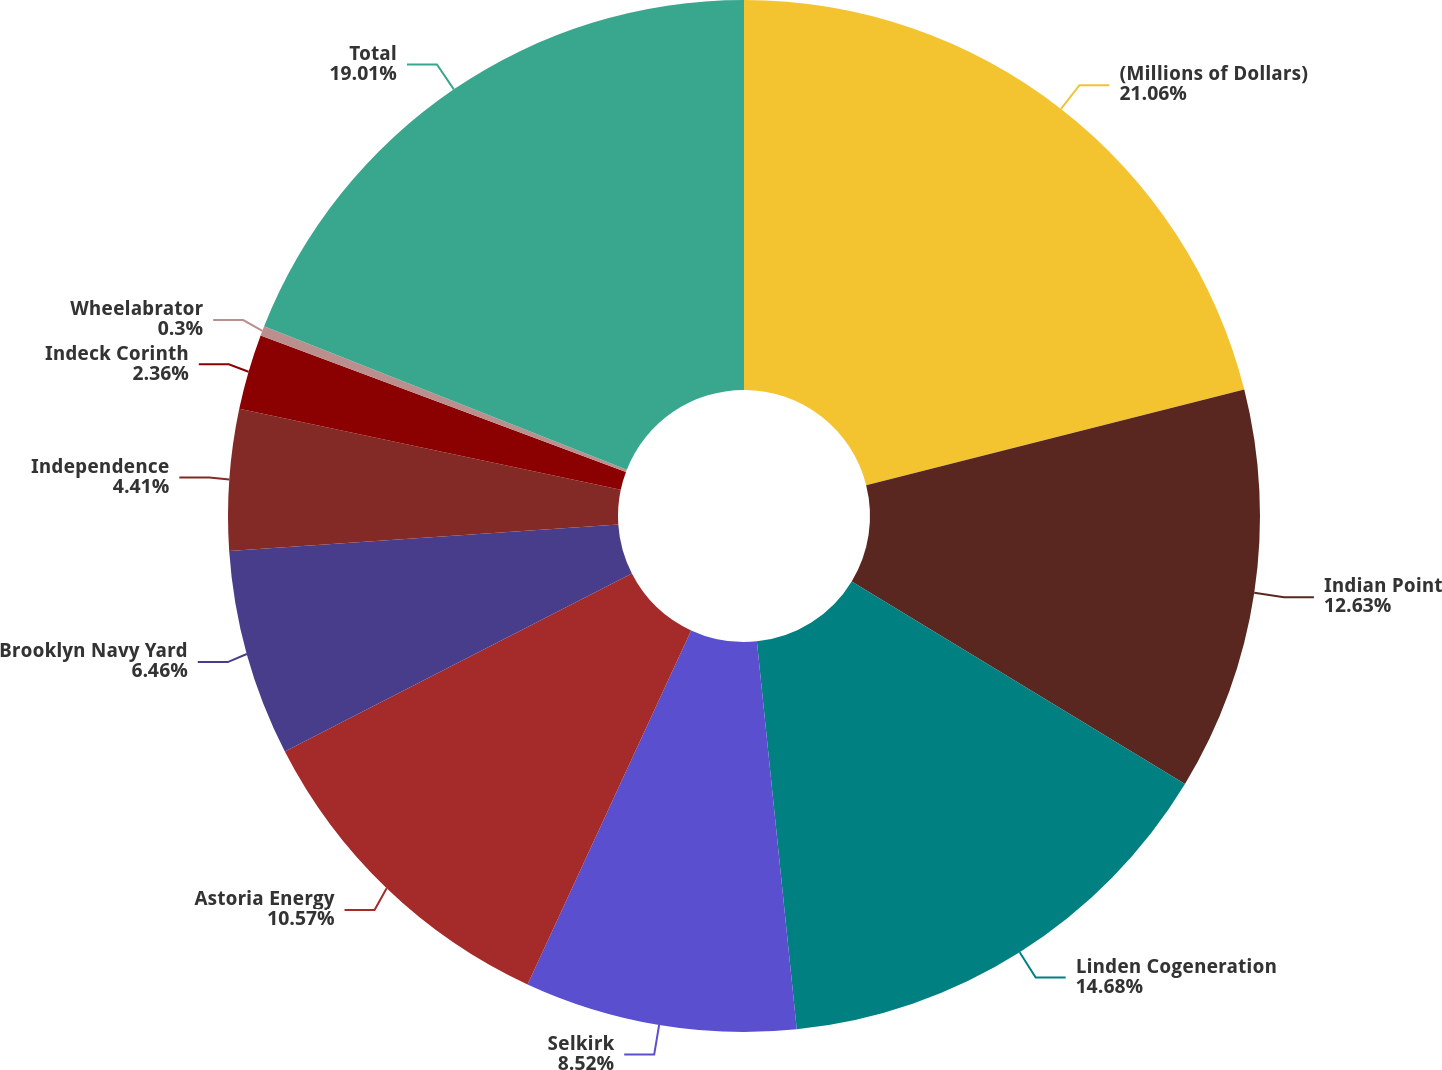Convert chart to OTSL. <chart><loc_0><loc_0><loc_500><loc_500><pie_chart><fcel>(Millions of Dollars)<fcel>Indian Point<fcel>Linden Cogeneration<fcel>Selkirk<fcel>Astoria Energy<fcel>Brooklyn Navy Yard<fcel>Independence<fcel>Indeck Corinth<fcel>Wheelabrator<fcel>Total<nl><fcel>21.06%<fcel>12.63%<fcel>14.68%<fcel>8.52%<fcel>10.57%<fcel>6.46%<fcel>4.41%<fcel>2.36%<fcel>0.3%<fcel>19.01%<nl></chart> 